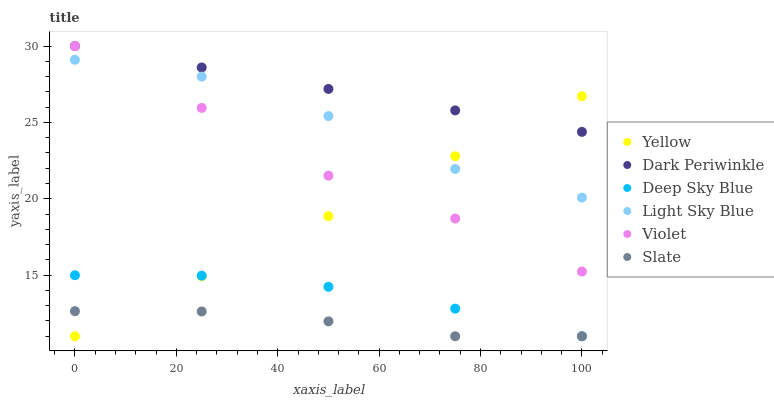Does Slate have the minimum area under the curve?
Answer yes or no. Yes. Does Dark Periwinkle have the maximum area under the curve?
Answer yes or no. Yes. Does Yellow have the minimum area under the curve?
Answer yes or no. No. Does Yellow have the maximum area under the curve?
Answer yes or no. No. Is Yellow the smoothest?
Answer yes or no. Yes. Is Light Sky Blue the roughest?
Answer yes or no. Yes. Is Light Sky Blue the smoothest?
Answer yes or no. No. Is Yellow the roughest?
Answer yes or no. No. Does Slate have the lowest value?
Answer yes or no. Yes. Does Light Sky Blue have the lowest value?
Answer yes or no. No. Does Dark Periwinkle have the highest value?
Answer yes or no. Yes. Does Yellow have the highest value?
Answer yes or no. No. Is Deep Sky Blue less than Light Sky Blue?
Answer yes or no. Yes. Is Light Sky Blue greater than Deep Sky Blue?
Answer yes or no. Yes. Does Yellow intersect Light Sky Blue?
Answer yes or no. Yes. Is Yellow less than Light Sky Blue?
Answer yes or no. No. Is Yellow greater than Light Sky Blue?
Answer yes or no. No. Does Deep Sky Blue intersect Light Sky Blue?
Answer yes or no. No. 